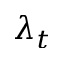<formula> <loc_0><loc_0><loc_500><loc_500>\lambda _ { t }</formula> 